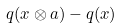<formula> <loc_0><loc_0><loc_500><loc_500>q ( x \otimes a ) - q ( x )</formula> 